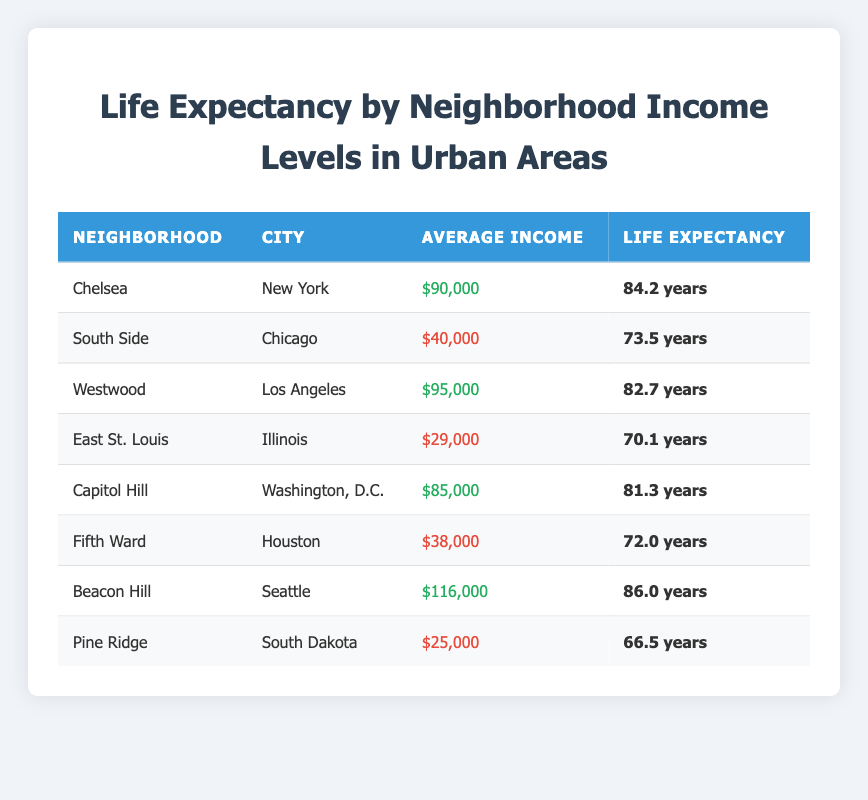What is the life expectancy in Chelsea? The table shows that Chelsea has a life expectancy of 84.2 years.
Answer: 84.2 years What is the average income of the South Side neighborhood? According to the table, the average income of the South Side neighborhood is $40,000.
Answer: $40,000 Is the life expectancy in Beacon Hill higher than 85 years? The table indicates that the life expectancy in Beacon Hill is 86.0 years, which is higher than 85 years.
Answer: Yes What is the difference in life expectancy between East St. Louis and Westwood? East St. Louis has a life expectancy of 70.1 years, while Westwood has 82.7 years. The difference is 82.7 - 70.1 = 12.6 years.
Answer: 12.6 years Calculate the average life expectancy for the neighborhoods with average incomes above $80,000. The neighborhoods with incomes above $80,000 are Chelsea (84.2 years), Westwood (82.7 years), Capitol Hill (81.3 years), and Beacon Hill (86.0 years). The average life expectancy is (84.2 + 82.7 + 81.3 + 86.0) / 4 = 83.3 years.
Answer: 83.3 years Which neighborhood has the lowest life expectancy? From the table, Pine Ridge has the lowest life expectancy at 66.5 years.
Answer: Pine Ridge Is the average income of Fifth Ward above or below $40,000? The table shows that Fifth Ward has an average income of $38,000, which is below $40,000.
Answer: Below What is the average life expectancy of neighborhoods with low average incomes? The neighborhoods with low average incomes are South Side (73.5 years), East St. Louis (70.1 years), Fifth Ward (72.0 years), and Pine Ridge (66.5 years). The average is (73.5 + 70.1 + 72.0 + 66.5) / 4 = 70.3 years.
Answer: 70.3 years 